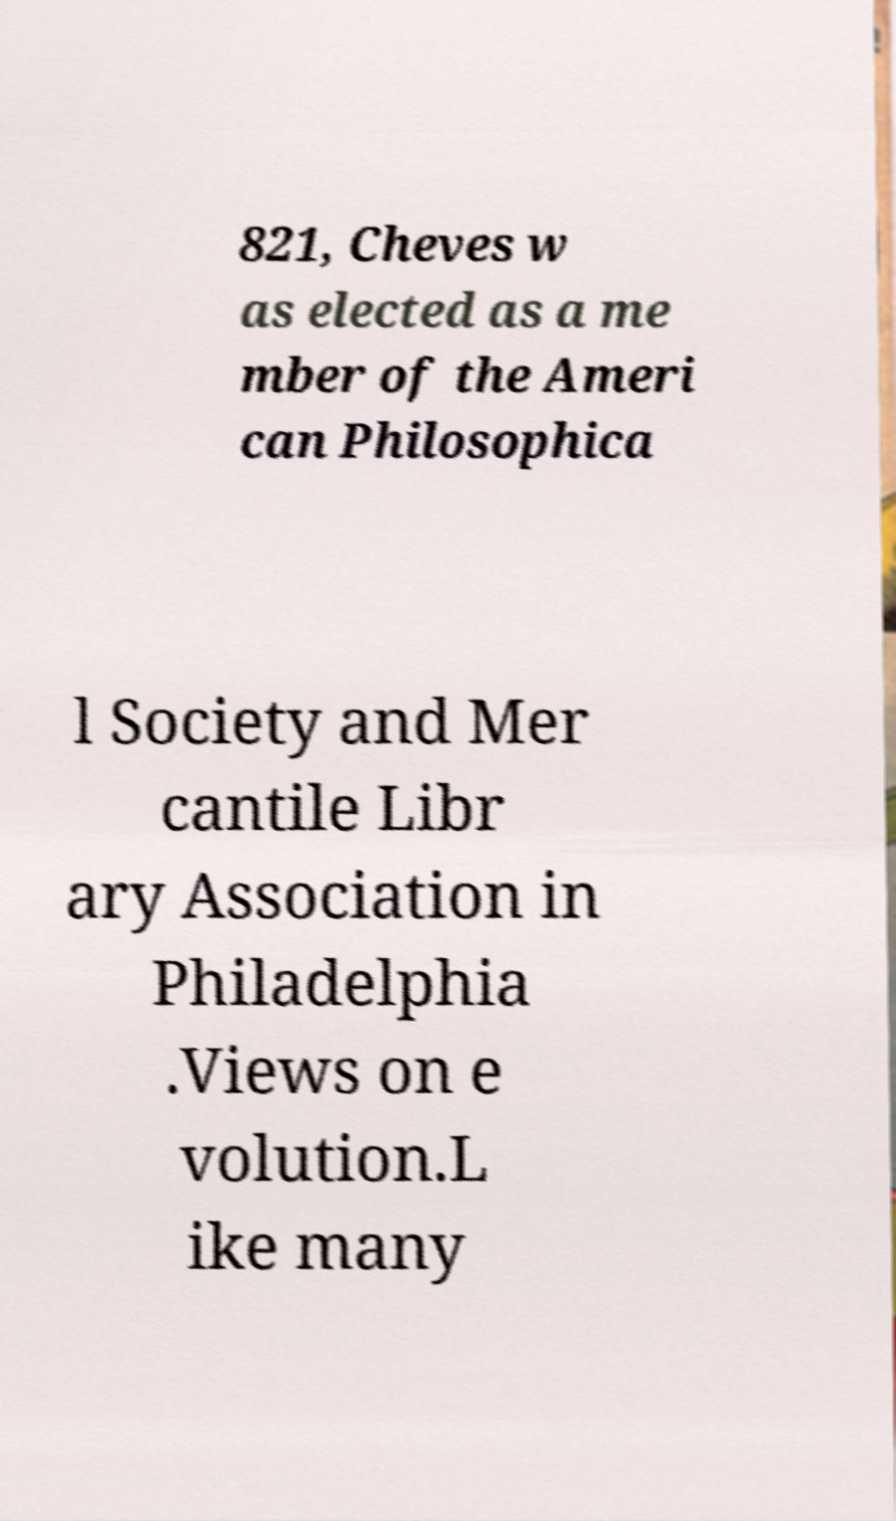Can you read and provide the text displayed in the image?This photo seems to have some interesting text. Can you extract and type it out for me? 821, Cheves w as elected as a me mber of the Ameri can Philosophica l Society and Mer cantile Libr ary Association in Philadelphia .Views on e volution.L ike many 